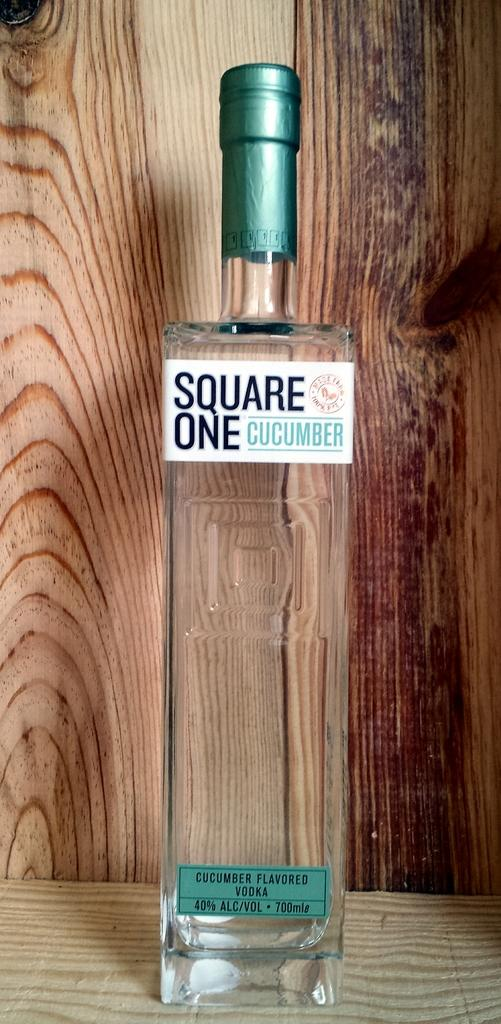<image>
Create a compact narrative representing the image presented. A bottle of Square One Cucumber flavored vodka. 